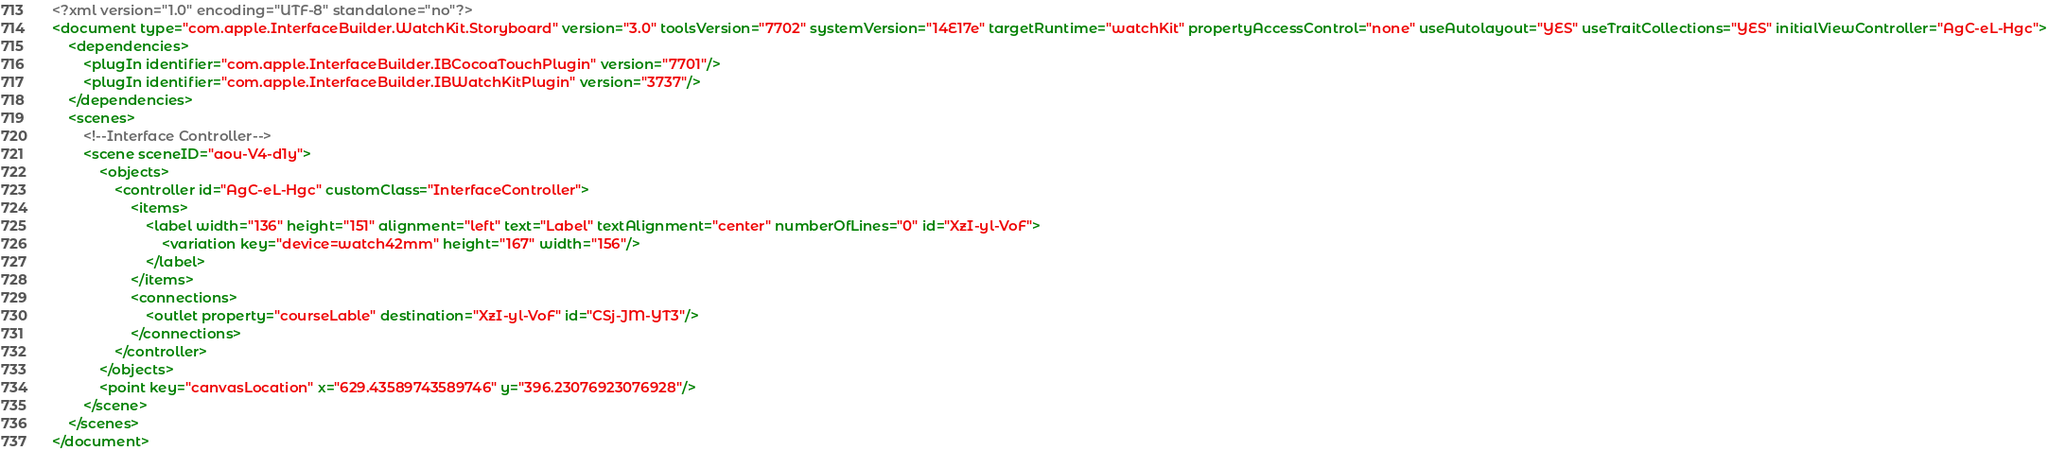Convert code to text. <code><loc_0><loc_0><loc_500><loc_500><_XML_><?xml version="1.0" encoding="UTF-8" standalone="no"?>
<document type="com.apple.InterfaceBuilder.WatchKit.Storyboard" version="3.0" toolsVersion="7702" systemVersion="14E17e" targetRuntime="watchKit" propertyAccessControl="none" useAutolayout="YES" useTraitCollections="YES" initialViewController="AgC-eL-Hgc">
    <dependencies>
        <plugIn identifier="com.apple.InterfaceBuilder.IBCocoaTouchPlugin" version="7701"/>
        <plugIn identifier="com.apple.InterfaceBuilder.IBWatchKitPlugin" version="3737"/>
    </dependencies>
    <scenes>
        <!--Interface Controller-->
        <scene sceneID="aou-V4-d1y">
            <objects>
                <controller id="AgC-eL-Hgc" customClass="InterfaceController">
                    <items>
                        <label width="136" height="151" alignment="left" text="Label" textAlignment="center" numberOfLines="0" id="XzI-yl-VoF">
                            <variation key="device=watch42mm" height="167" width="156"/>
                        </label>
                    </items>
                    <connections>
                        <outlet property="courseLable" destination="XzI-yl-VoF" id="CSj-JM-YT3"/>
                    </connections>
                </controller>
            </objects>
            <point key="canvasLocation" x="629.43589743589746" y="396.23076923076928"/>
        </scene>
    </scenes>
</document>
</code> 